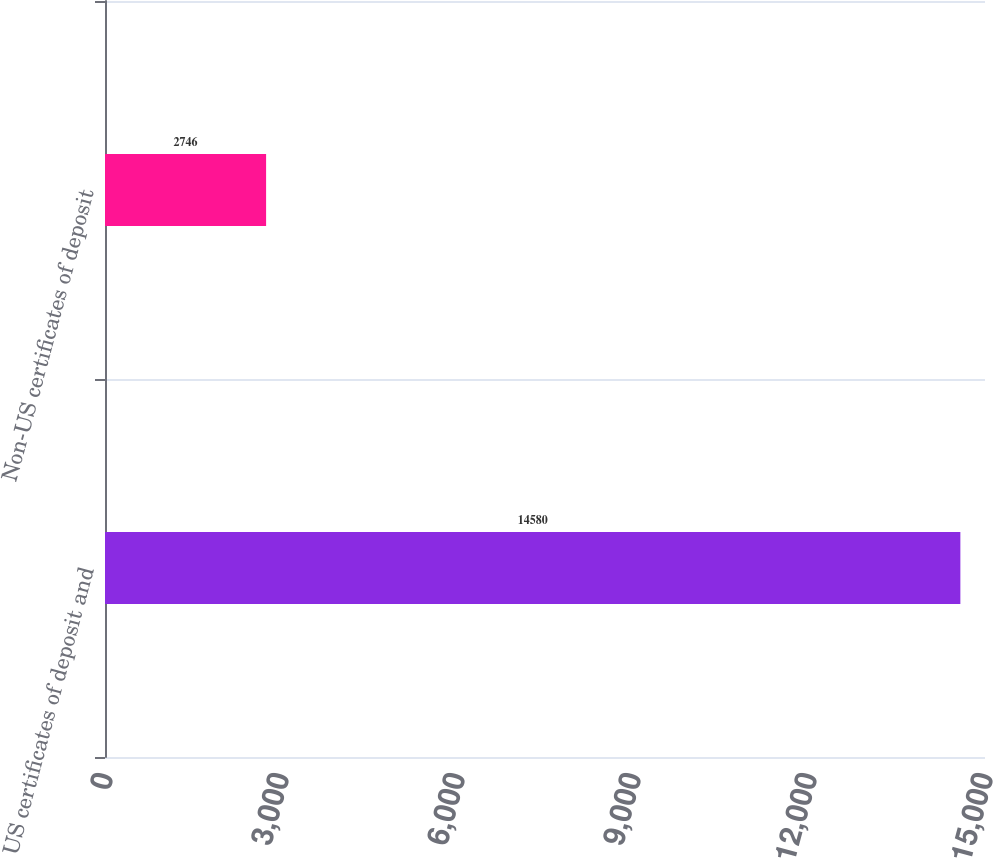Convert chart. <chart><loc_0><loc_0><loc_500><loc_500><bar_chart><fcel>US certificates of deposit and<fcel>Non-US certificates of deposit<nl><fcel>14580<fcel>2746<nl></chart> 